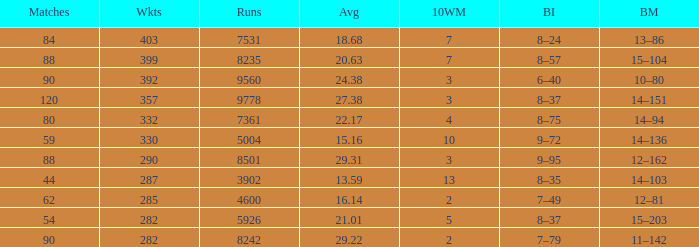How many wickets have runs under 7531, matches over 44, and an average of 22.17? 332.0. Can you give me this table as a dict? {'header': ['Matches', 'Wkts', 'Runs', 'Avg', '10WM', 'BI', 'BM'], 'rows': [['84', '403', '7531', '18.68', '7', '8–24', '13–86'], ['88', '399', '8235', '20.63', '7', '8–57', '15–104'], ['90', '392', '9560', '24.38', '3', '6–40', '10–80'], ['120', '357', '9778', '27.38', '3', '8–37', '14–151'], ['80', '332', '7361', '22.17', '4', '8–75', '14–94'], ['59', '330', '5004', '15.16', '10', '9–72', '14–136'], ['88', '290', '8501', '29.31', '3', '9–95', '12–162'], ['44', '287', '3902', '13.59', '13', '8–35', '14–103'], ['62', '285', '4600', '16.14', '2', '7–49', '12–81'], ['54', '282', '5926', '21.01', '5', '8–37', '15–203'], ['90', '282', '8242', '29.22', '2', '7–79', '11–142']]} 